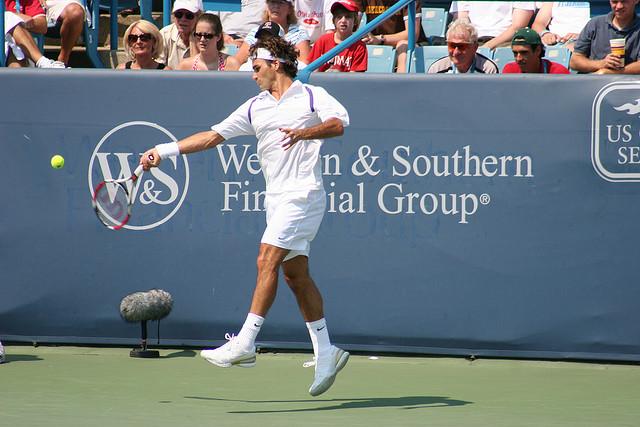Who is this tennis player?
Answer briefly. Nidal. What color is the tennis players wristband?
Concise answer only. White. Which hand is the tennis player using to hold the racquet?
Keep it brief. Right. 